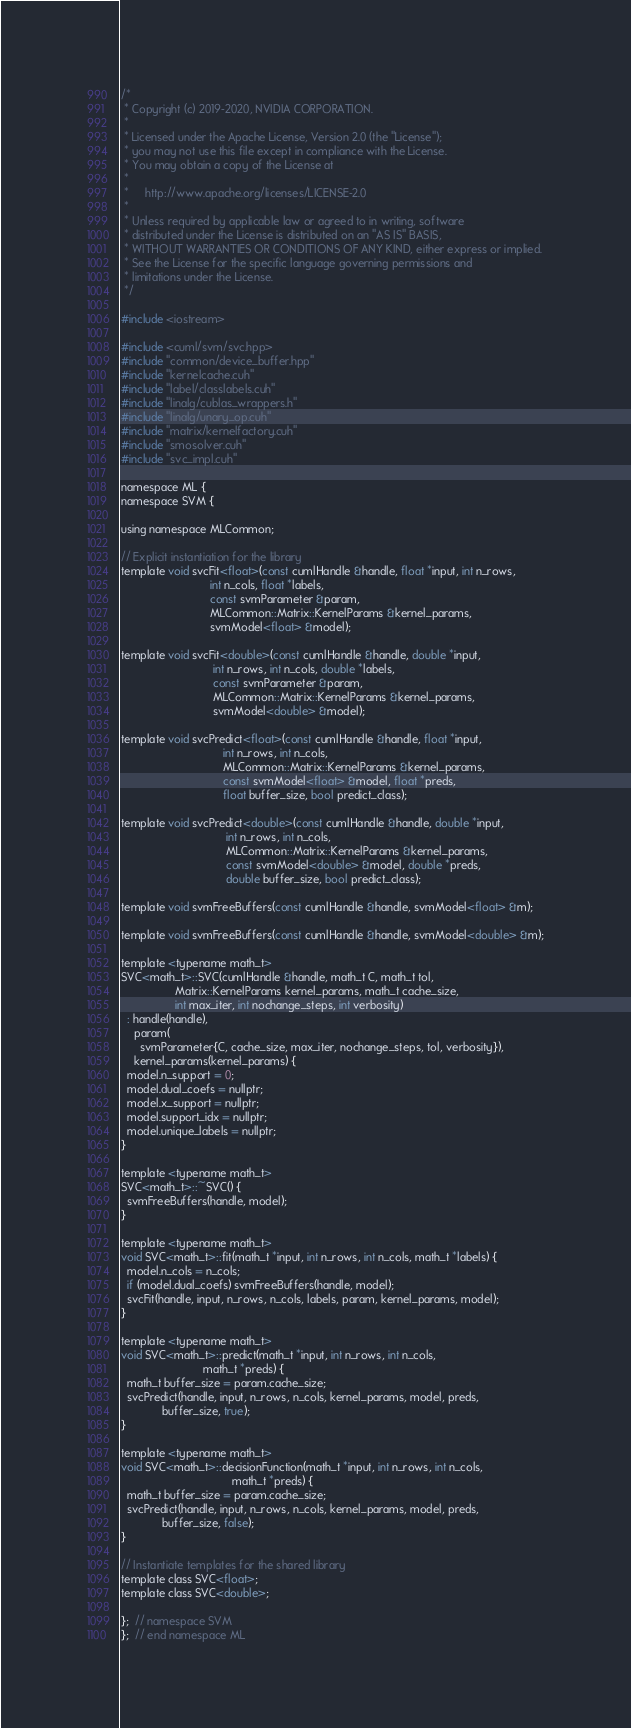<code> <loc_0><loc_0><loc_500><loc_500><_Cuda_>/*
 * Copyright (c) 2019-2020, NVIDIA CORPORATION.
 *
 * Licensed under the Apache License, Version 2.0 (the "License");
 * you may not use this file except in compliance with the License.
 * You may obtain a copy of the License at
 *
 *     http://www.apache.org/licenses/LICENSE-2.0
 *
 * Unless required by applicable law or agreed to in writing, software
 * distributed under the License is distributed on an "AS IS" BASIS,
 * WITHOUT WARRANTIES OR CONDITIONS OF ANY KIND, either express or implied.
 * See the License for the specific language governing permissions and
 * limitations under the License.
 */

#include <iostream>

#include <cuml/svm/svc.hpp>
#include "common/device_buffer.hpp"
#include "kernelcache.cuh"
#include "label/classlabels.cuh"
#include "linalg/cublas_wrappers.h"
#include "linalg/unary_op.cuh"
#include "matrix/kernelfactory.cuh"
#include "smosolver.cuh"
#include "svc_impl.cuh"

namespace ML {
namespace SVM {

using namespace MLCommon;

// Explicit instantiation for the library
template void svcFit<float>(const cumlHandle &handle, float *input, int n_rows,
                            int n_cols, float *labels,
                            const svmParameter &param,
                            MLCommon::Matrix::KernelParams &kernel_params,
                            svmModel<float> &model);

template void svcFit<double>(const cumlHandle &handle, double *input,
                             int n_rows, int n_cols, double *labels,
                             const svmParameter &param,
                             MLCommon::Matrix::KernelParams &kernel_params,
                             svmModel<double> &model);

template void svcPredict<float>(const cumlHandle &handle, float *input,
                                int n_rows, int n_cols,
                                MLCommon::Matrix::KernelParams &kernel_params,
                                const svmModel<float> &model, float *preds,
                                float buffer_size, bool predict_class);

template void svcPredict<double>(const cumlHandle &handle, double *input,
                                 int n_rows, int n_cols,
                                 MLCommon::Matrix::KernelParams &kernel_params,
                                 const svmModel<double> &model, double *preds,
                                 double buffer_size, bool predict_class);

template void svmFreeBuffers(const cumlHandle &handle, svmModel<float> &m);

template void svmFreeBuffers(const cumlHandle &handle, svmModel<double> &m);

template <typename math_t>
SVC<math_t>::SVC(cumlHandle &handle, math_t C, math_t tol,
                 Matrix::KernelParams kernel_params, math_t cache_size,
                 int max_iter, int nochange_steps, int verbosity)
  : handle(handle),
    param(
      svmParameter{C, cache_size, max_iter, nochange_steps, tol, verbosity}),
    kernel_params(kernel_params) {
  model.n_support = 0;
  model.dual_coefs = nullptr;
  model.x_support = nullptr;
  model.support_idx = nullptr;
  model.unique_labels = nullptr;
}

template <typename math_t>
SVC<math_t>::~SVC() {
  svmFreeBuffers(handle, model);
}

template <typename math_t>
void SVC<math_t>::fit(math_t *input, int n_rows, int n_cols, math_t *labels) {
  model.n_cols = n_cols;
  if (model.dual_coefs) svmFreeBuffers(handle, model);
  svcFit(handle, input, n_rows, n_cols, labels, param, kernel_params, model);
}

template <typename math_t>
void SVC<math_t>::predict(math_t *input, int n_rows, int n_cols,
                          math_t *preds) {
  math_t buffer_size = param.cache_size;
  svcPredict(handle, input, n_rows, n_cols, kernel_params, model, preds,
             buffer_size, true);
}

template <typename math_t>
void SVC<math_t>::decisionFunction(math_t *input, int n_rows, int n_cols,
                                   math_t *preds) {
  math_t buffer_size = param.cache_size;
  svcPredict(handle, input, n_rows, n_cols, kernel_params, model, preds,
             buffer_size, false);
}

// Instantiate templates for the shared library
template class SVC<float>;
template class SVC<double>;

};  // namespace SVM
};  // end namespace ML
</code> 